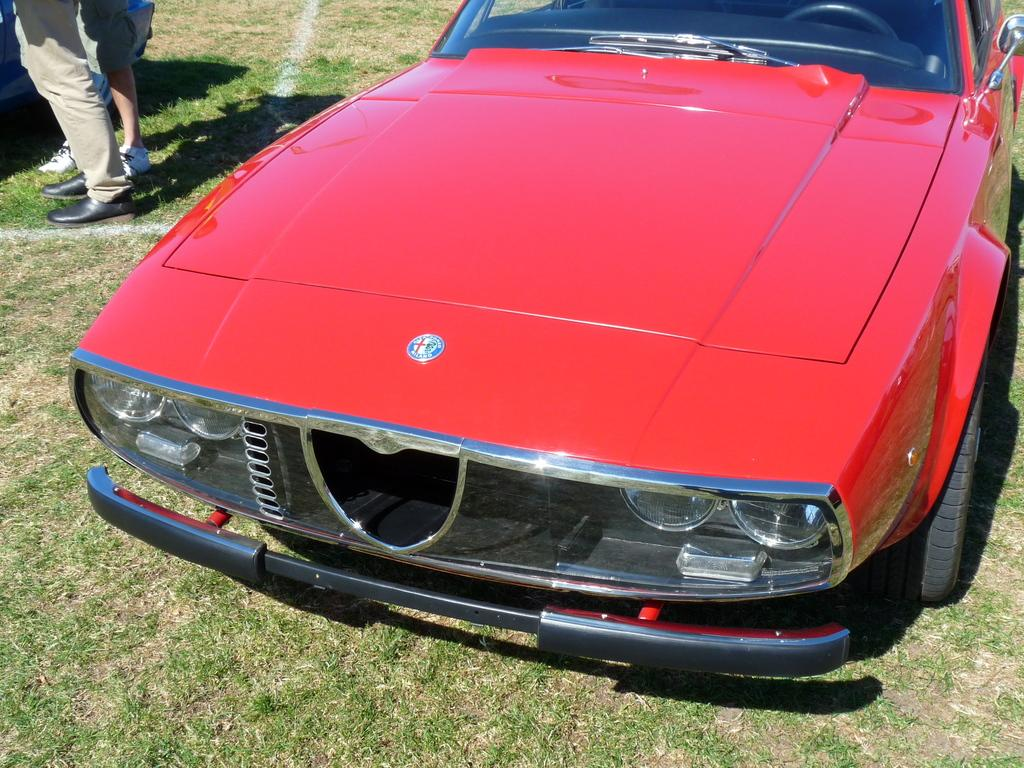What type of vehicle is in the image? There is a red car in the image. What can be seen in the background of the image? There is grass in the background of the image. What color is the grass? The grass is green. Are there any other people visible in the image? Yes, there are other persons standing in the background of the image. What type of calculator is being used by the throat in the image? There is no calculator or reference to a throat present in the image. 